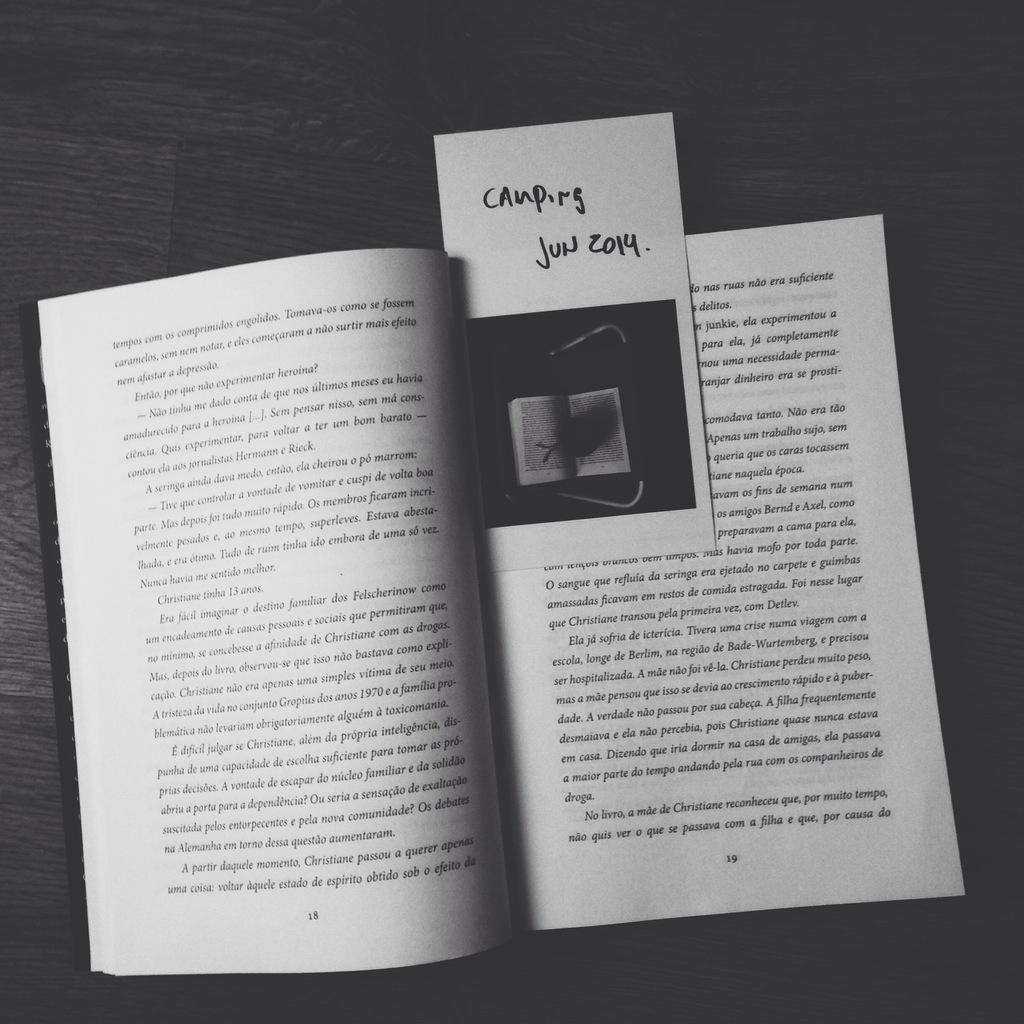<image>
Render a clear and concise summary of the photo. A bookmark with the words Canpirs Jun 2014 written on it marking a place in an open book. 